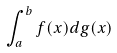Convert formula to latex. <formula><loc_0><loc_0><loc_500><loc_500>\int _ { a } ^ { b } f ( x ) d g ( x )</formula> 